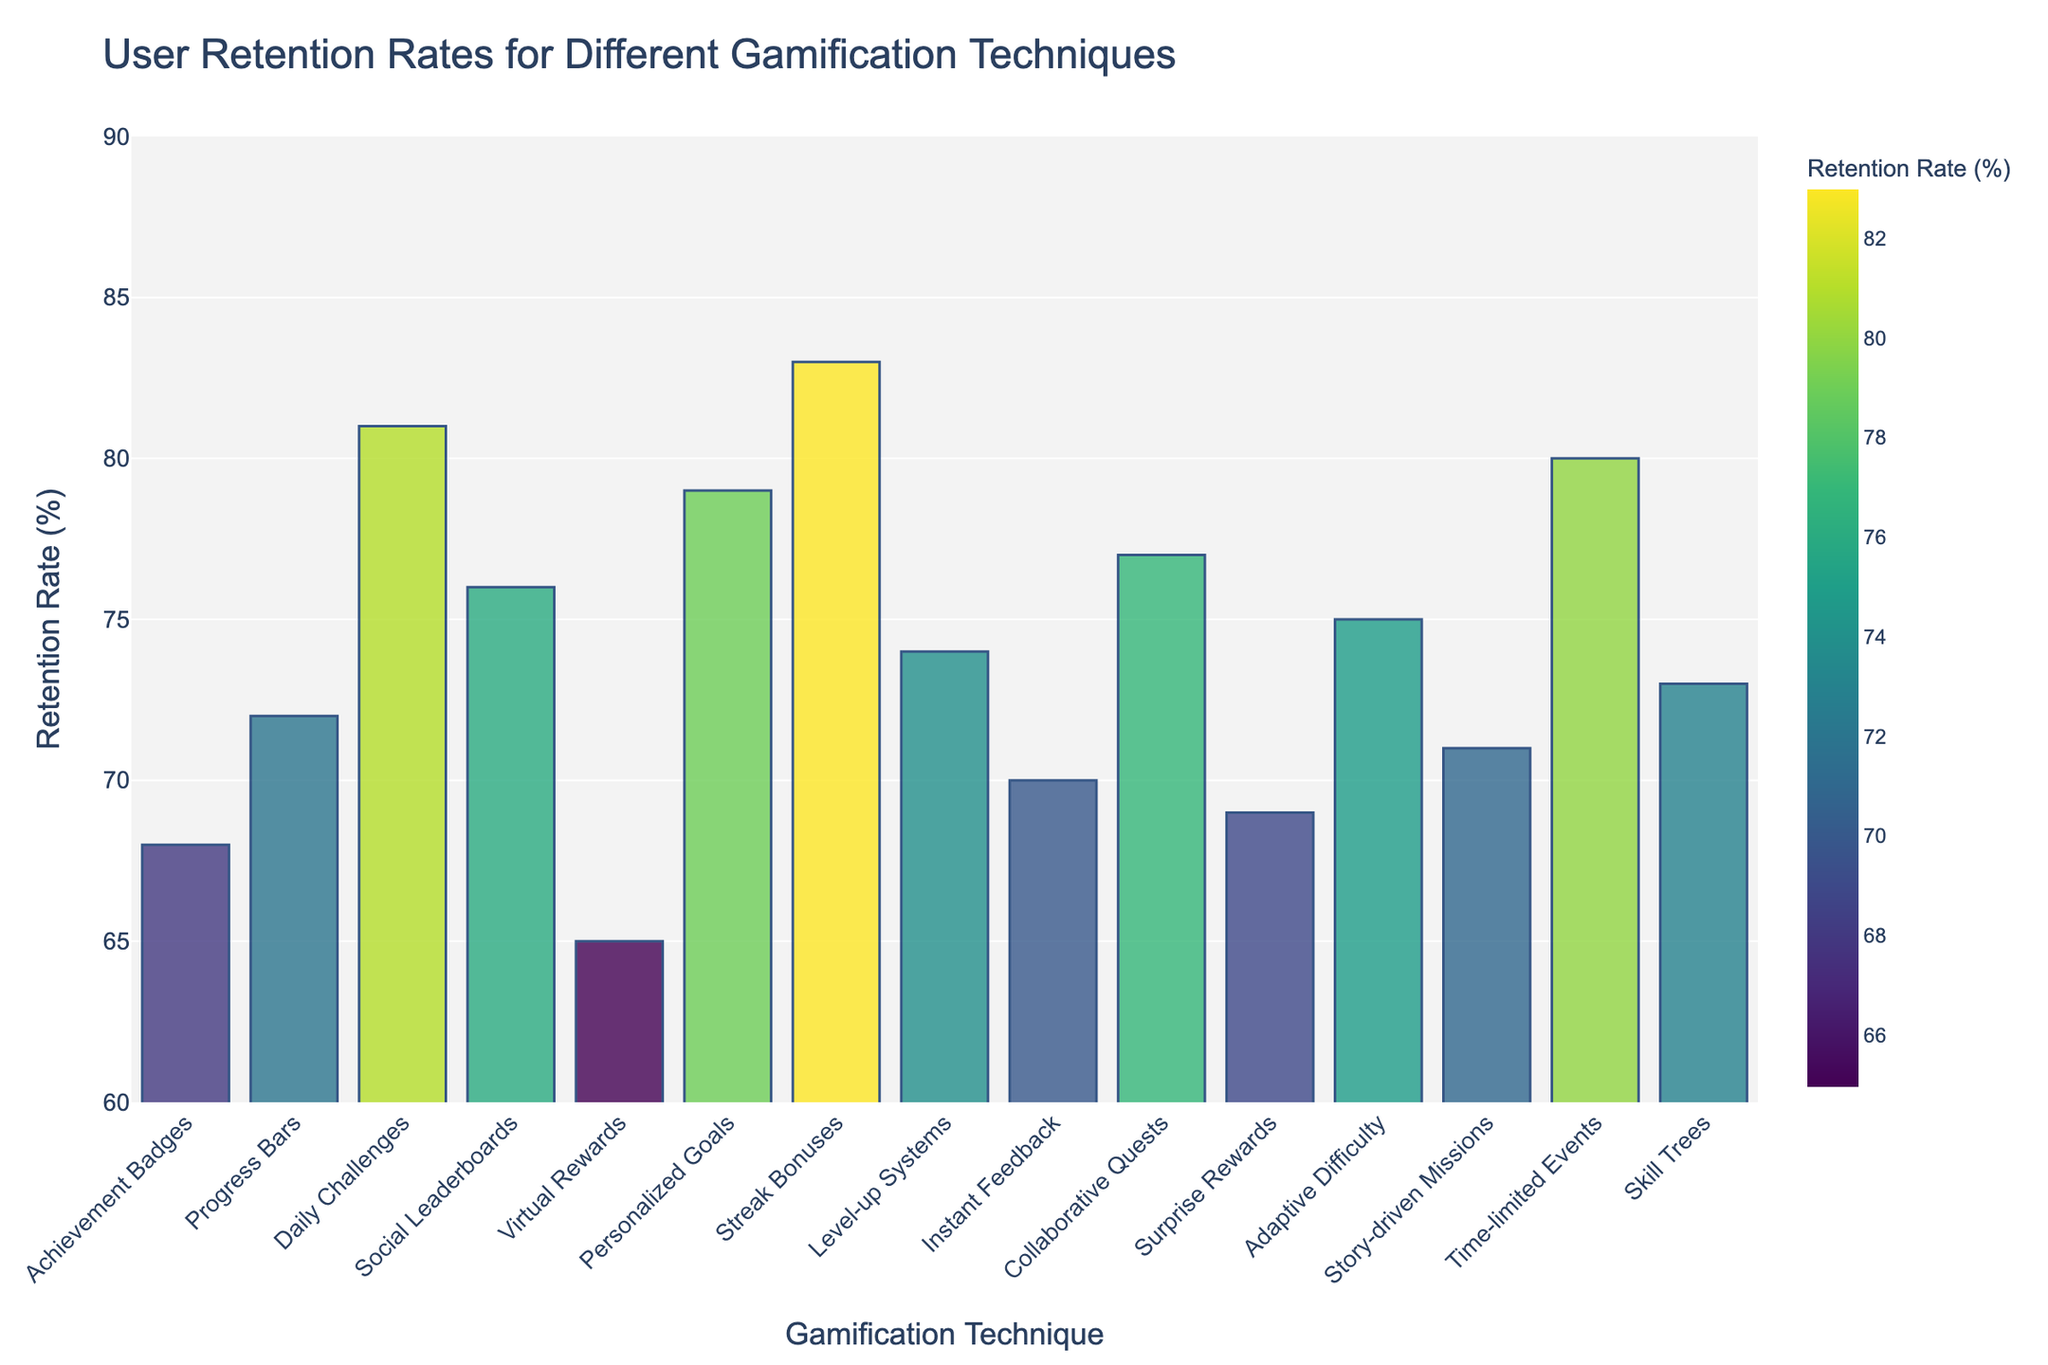Which gamification technique has the highest user retention rate? The bar for 'Streak Bonuses' is the tallest among all the bars, indicating it has the highest retention rate.
Answer: Streak Bonuses Which gamification technique has a user retention rate below 70%? The bars for 'Virtual Rewards' and 'Surprise Rewards' both fall below the 70% mark on the y-axis.
Answer: Virtual Rewards and Surprise Rewards Compare 'Daily Challenges' and 'Time-limited Events': Which one has a higher user retention rate? The retention rate for 'Daily Challenges' is 81%, while 'Time-limited Events' have a retention rate of 80%. Thus, 'Daily Challenges' is higher.
Answer: Daily Challenges What is the difference in user retention rate between 'Collaborative Quests' and 'Achievement Badges'? 'Collaborative Quests' have a retention rate of 77%, and 'Achievement Badges' have 68%. The difference is 77% - 68% = 9%.
Answer: 9% Calculate the average user retention rate for 'Progress Bars', 'Level-up Systems', and 'Skill Trees'. The retention rates are 72%, 74%, and 73%, respectively. The average is (72% + 74% + 73%) / 3 = 219% / 3 = 73%.
Answer: 73% Which gamification techniques have a user retention rate equal to or above 80%? The bars for 'Daily Challenges', 'Time-limited Events', and 'Streak Bonuses' reach or exceed the 80% mark.
Answer: Daily Challenges, Time-limited Events, and Streak Bonuses Order the techniques 'Achievement Badges', 'Instant Feedback', and 'Personalized Goals' from highest to lowest user retention rate. 'Personalized Goals' has 79%, 'Instant Feedback' has 70%, 'Achievement Badges' has 68%. So the order is 'Personalized Goals' > 'Instant Feedback' > 'Achievement Badges'.
Answer: Personalized Goals > Instant Feedback > Achievement Badges Which technique's bar color appears the darkest on the chart? The color darkens as the retention rate increases. The bar for 'Streak Bonuses' would appear the darkest because it has the highest retention rate.
Answer: Streak Bonuses What's the median user retention rate among all techniques? First, list all retention rates: 68, 72, 81, 76, 65, 79, 83, 74, 70, 77, 69, 75, 71, 80, 73. Arrange them in order and find the middle value. The median is the 8th value in this sorted list: 68, 69, 70, 71, 72, 73, 74, 75, 76, 77, 79, 80, 81, 83.
Answer: 75 Does 'Story-driven Missions' have a higher retention rate than 'Skill Trees'? 'Story-driven Missions' have a user retention rate of 71%, whereas 'Skill Trees' have 73%. Therefore, 'Story-driven Missions' have a lower retention rate.
Answer: No 